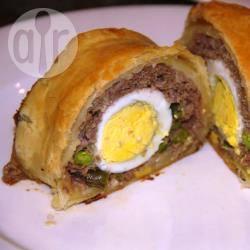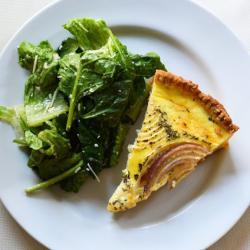The first image is the image on the left, the second image is the image on the right. Examine the images to the left and right. Is the description "In the image on the left, the dough products are arranged neatly on a baking sheet." accurate? Answer yes or no. No. 